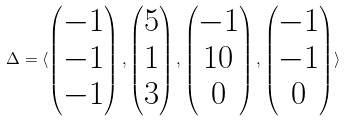<formula> <loc_0><loc_0><loc_500><loc_500>\Delta = \langle \begin{pmatrix} - 1 \\ - 1 \\ - 1 \end{pmatrix} , \begin{pmatrix} 5 \\ 1 \\ 3 \end{pmatrix} , \begin{pmatrix} - 1 \\ 1 0 \\ 0 \end{pmatrix} , \begin{pmatrix} - 1 \\ - 1 \\ 0 \end{pmatrix} \rangle</formula> 